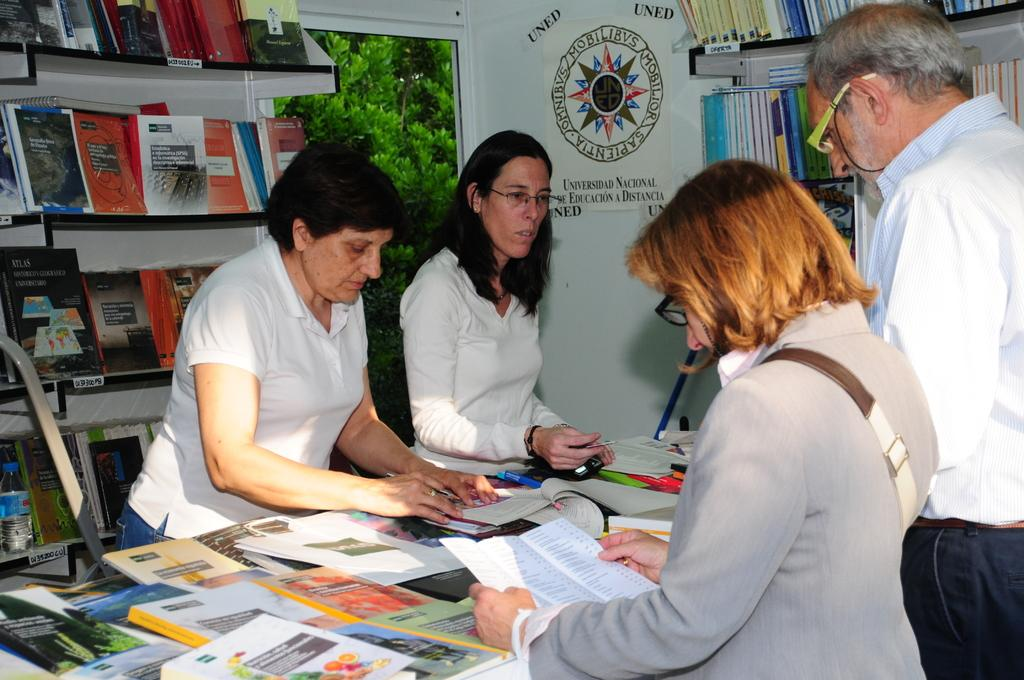<image>
Create a compact narrative representing the image presented. A group of people sort through a table of books in front of a sign that says UNED on it. 